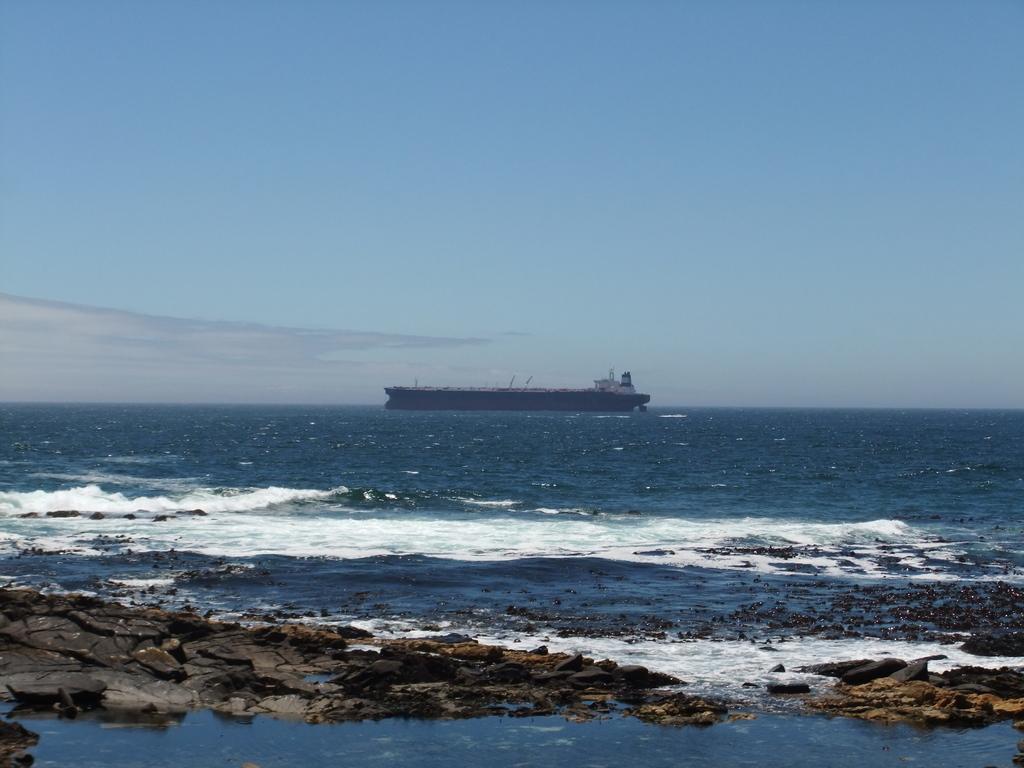In one or two sentences, can you explain what this image depicts? In the center of the image, we can see a ship and at the bottom, there is water and rocks. At the top, there is sky. 